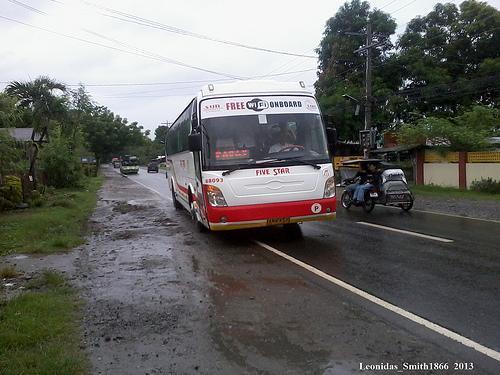How many headlights are on the bus?
Give a very brief answer. 2. 